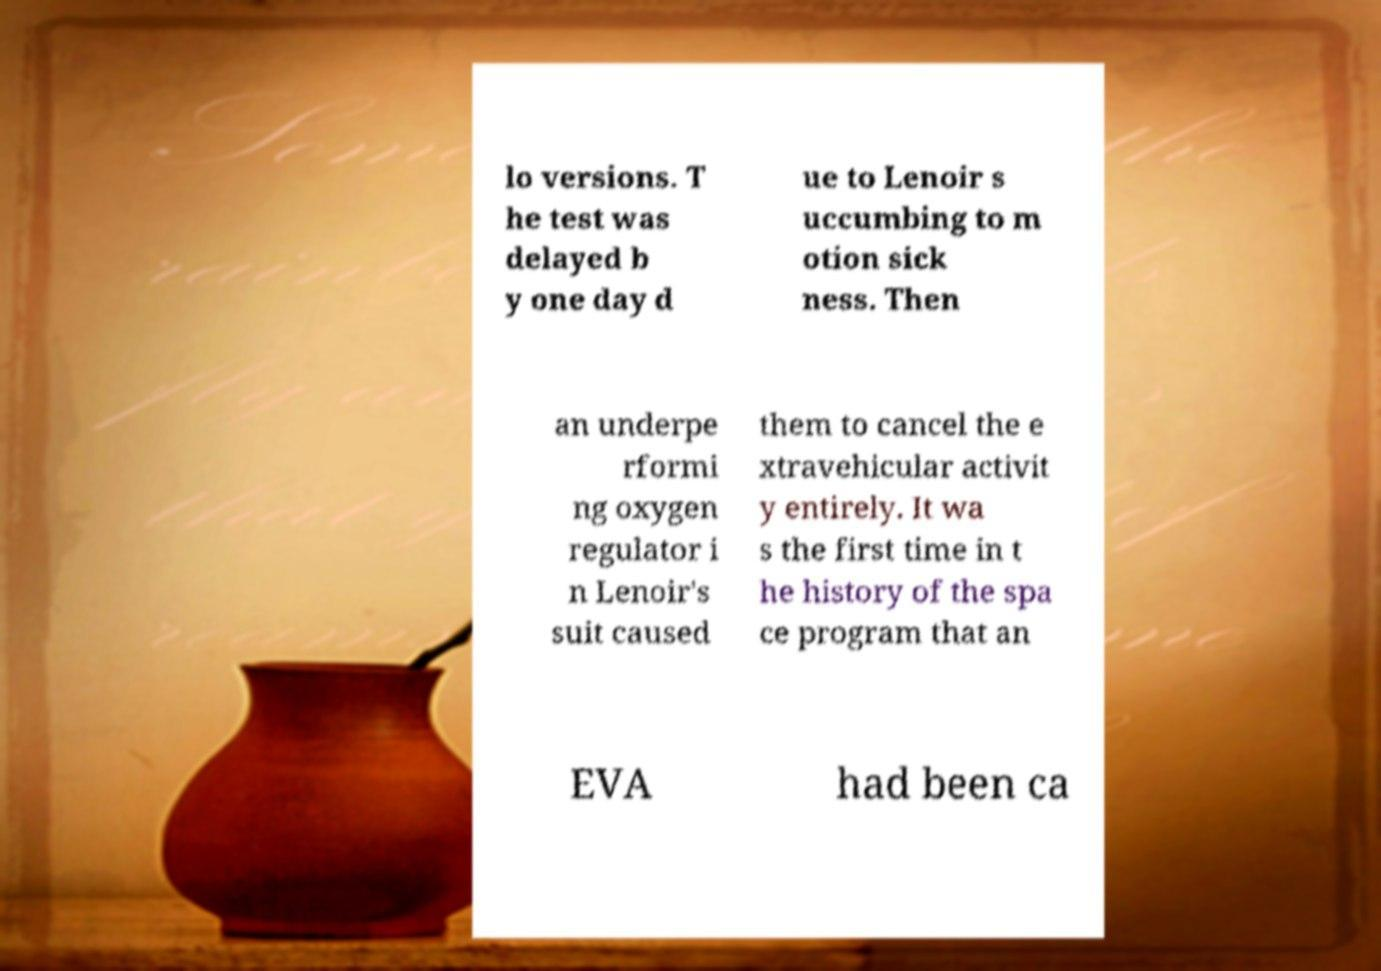For documentation purposes, I need the text within this image transcribed. Could you provide that? lo versions. T he test was delayed b y one day d ue to Lenoir s uccumbing to m otion sick ness. Then an underpe rformi ng oxygen regulator i n Lenoir's suit caused them to cancel the e xtravehicular activit y entirely. It wa s the first time in t he history of the spa ce program that an EVA had been ca 